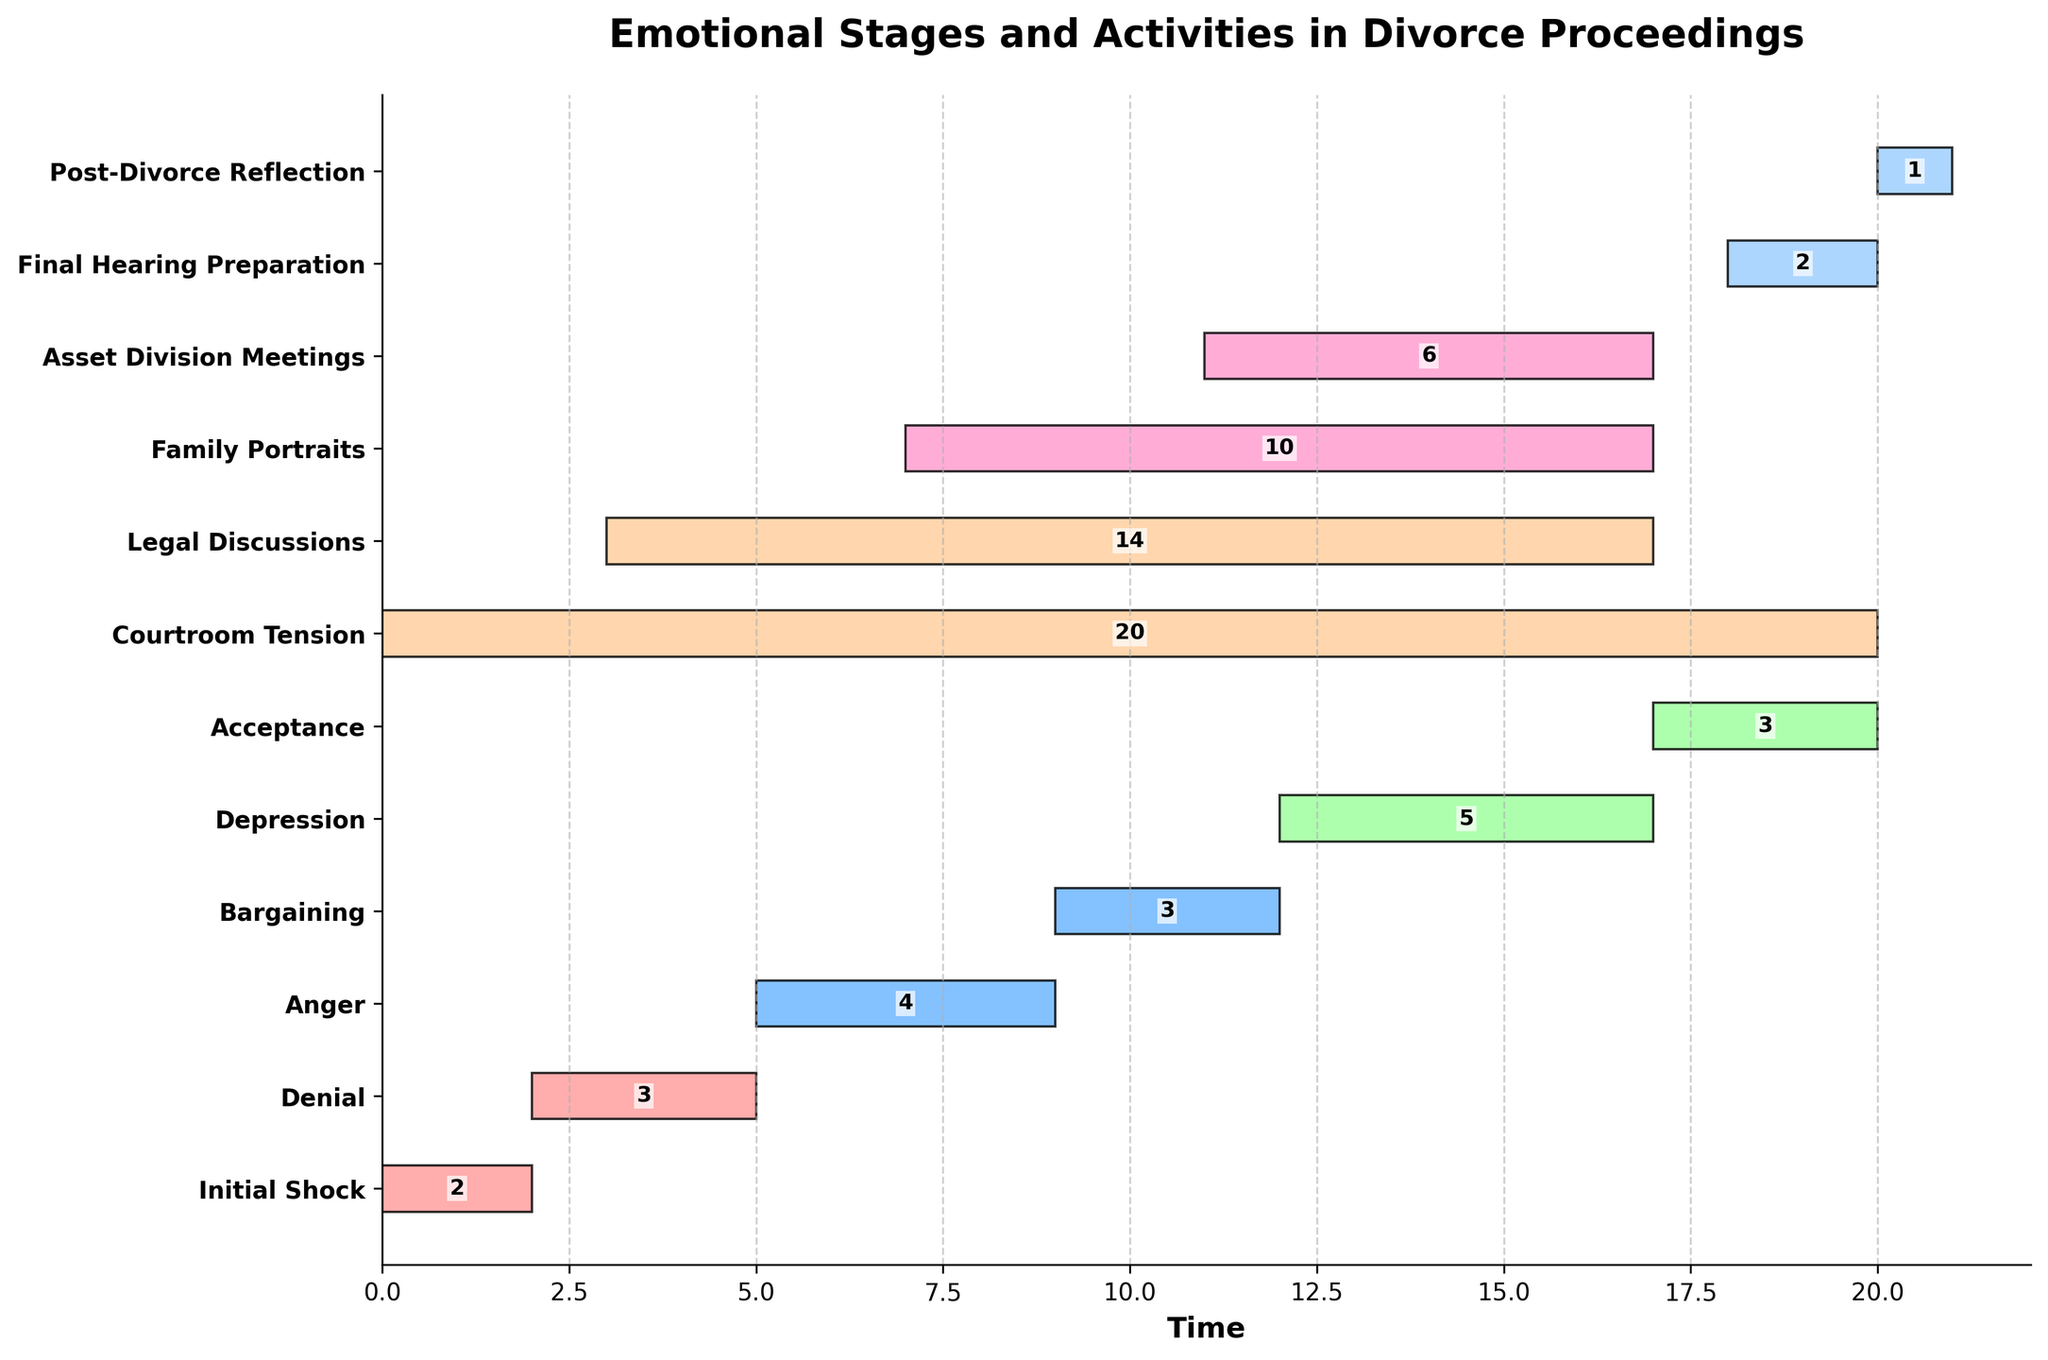What is the title of the Gantt Chart? The title of the chart is displayed at the top.
Answer: Emotional Stages and Activities in Divorce Proceedings Which task has the longest duration? By comparing the bar lengths, "Courtroom Tension" covers the longest timespan.
Answer: Courtroom Tension How long does the "Anger" stage last? The duration is written inside the bar for the "Anger" stage.
Answer: 4 What is the total time covered by all emotional stages combined? Sum the durations of all emotional stages: 2 (Initial Shock) + 3 (Denial) + 4 (Anger) + 3 (Bargaining) + 5 (Depression) + 3 (Acceptance).
Answer: 20 Which task starts at the same time as "Courtroom Tension" but lasts less time? Identify tasks starting at the same point as "Courtroom Tension" (0), then compare durations.
Answer: Initial Shock What tasks overlap during the 7th time unit? Check which tasks span across time unit 7 within their duration. Identify overlapping tasks.
Answer: Family Portraits, Anger, Legal Discussions What's the duration of the task that starts at time unit 11 and overlaps with "Depression"? "Asset Division Meetings" starts at 11 and its duration is shown inside the bar.
Answer: 6 Which two tasks have durations that add up to the length of "Courtroom Tension"? "Courtroom Tension" is 20 units long. Combining tasks to sum up to this, "Depression" (5) + "Legal Discussions" (14) + "Post-Divorce Reflection" (1) = 20.
Answer: Depression, Legal Discussions, Post-Divorce Reflection Which emotional stage occurs last and how long does it last? Identify the emotional stages and determine which one is last by position.
Answer: Acceptance, 3 